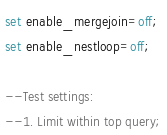Convert code to text. <code><loc_0><loc_0><loc_500><loc_500><_SQL_>set enable_mergejoin=off; 
set enable_nestloop=off; 

--Test settings:
--1. Limit within top query;</code> 